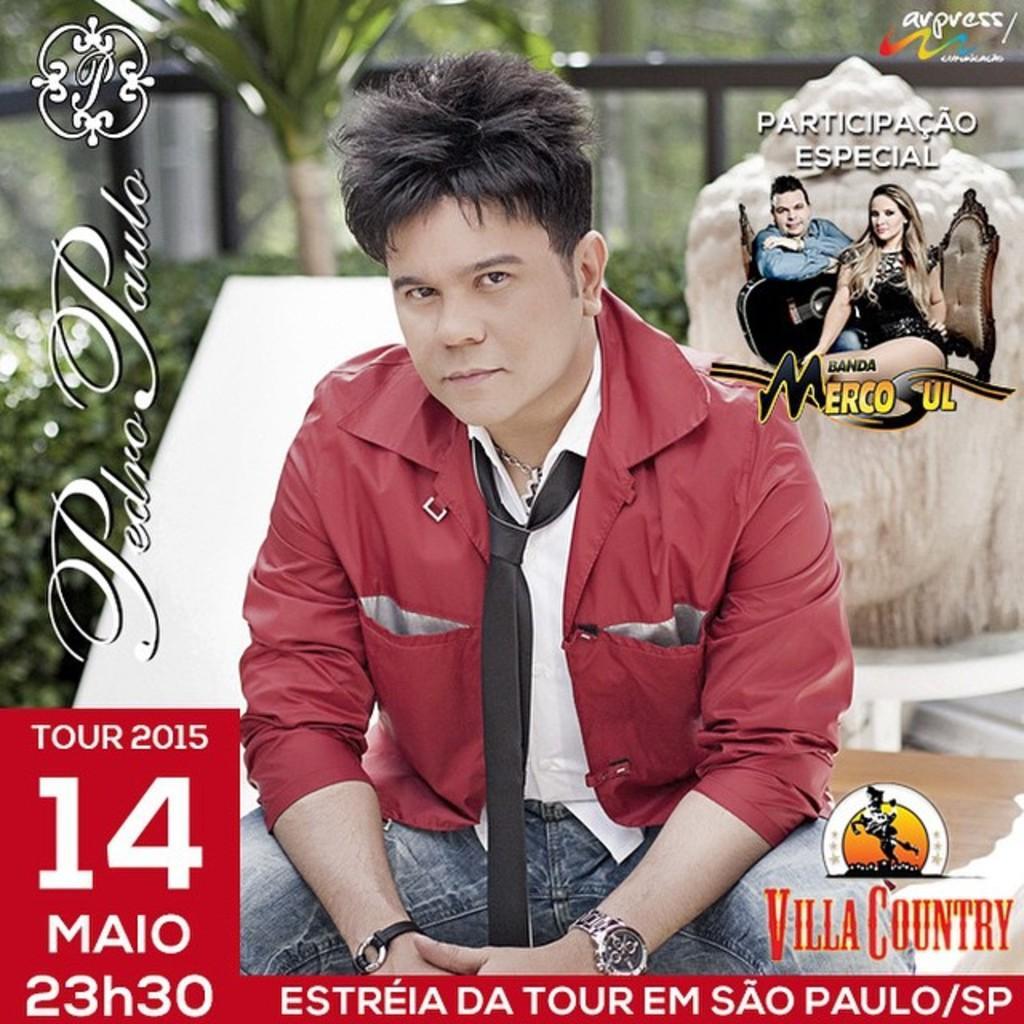Describe this image in one or two sentences. In this image I can see the person with white and red color dress and he is with the tie. To the right I can see rock. In the back I can see the trees and the railing. And I can see something is written on the image. 